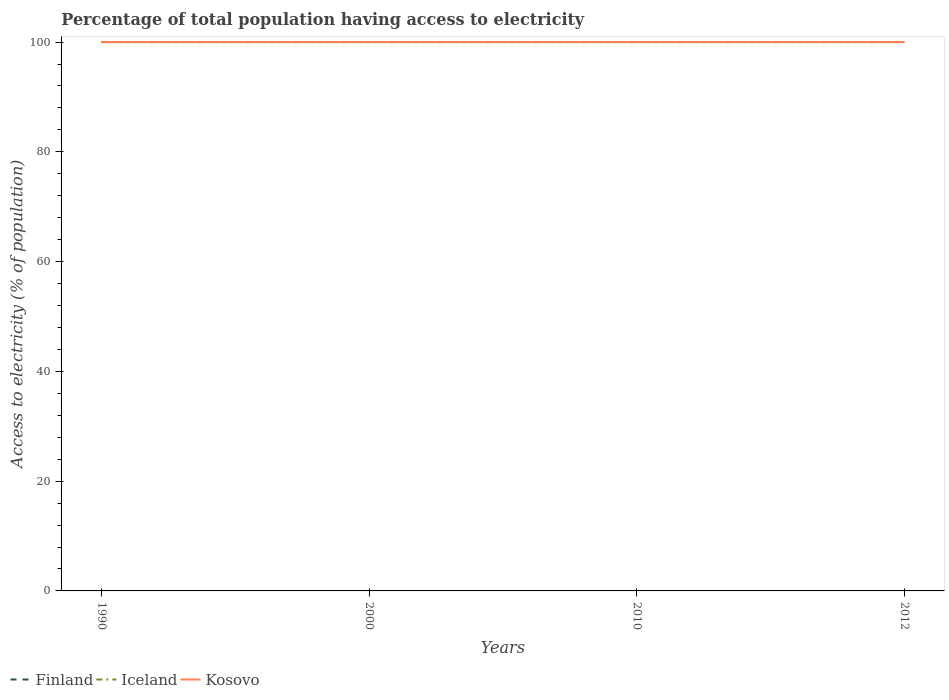How many different coloured lines are there?
Offer a terse response. 3. Is the number of lines equal to the number of legend labels?
Your response must be concise. Yes. Across all years, what is the maximum percentage of population that have access to electricity in Iceland?
Keep it short and to the point. 100. In which year was the percentage of population that have access to electricity in Kosovo maximum?
Make the answer very short. 1990. What is the difference between the highest and the lowest percentage of population that have access to electricity in Kosovo?
Offer a terse response. 0. How many lines are there?
Your answer should be very brief. 3. What is the difference between two consecutive major ticks on the Y-axis?
Offer a terse response. 20. How many legend labels are there?
Offer a very short reply. 3. What is the title of the graph?
Make the answer very short. Percentage of total population having access to electricity. Does "Congo (Democratic)" appear as one of the legend labels in the graph?
Your answer should be compact. No. What is the label or title of the Y-axis?
Your response must be concise. Access to electricity (% of population). What is the Access to electricity (% of population) of Iceland in 1990?
Ensure brevity in your answer.  100. What is the Access to electricity (% of population) of Iceland in 2000?
Provide a short and direct response. 100. What is the Access to electricity (% of population) of Kosovo in 2010?
Offer a terse response. 100. What is the Access to electricity (% of population) of Finland in 2012?
Your answer should be very brief. 100. What is the Access to electricity (% of population) in Iceland in 2012?
Your response must be concise. 100. Across all years, what is the maximum Access to electricity (% of population) of Iceland?
Offer a terse response. 100. Across all years, what is the minimum Access to electricity (% of population) in Kosovo?
Keep it short and to the point. 100. What is the total Access to electricity (% of population) of Kosovo in the graph?
Give a very brief answer. 400. What is the difference between the Access to electricity (% of population) in Iceland in 1990 and that in 2000?
Your answer should be very brief. 0. What is the difference between the Access to electricity (% of population) of Kosovo in 1990 and that in 2000?
Your answer should be compact. 0. What is the difference between the Access to electricity (% of population) of Kosovo in 1990 and that in 2010?
Offer a terse response. 0. What is the difference between the Access to electricity (% of population) of Finland in 1990 and that in 2012?
Offer a terse response. 0. What is the difference between the Access to electricity (% of population) in Kosovo in 2000 and that in 2010?
Your answer should be compact. 0. What is the difference between the Access to electricity (% of population) of Iceland in 2000 and that in 2012?
Your answer should be very brief. 0. What is the difference between the Access to electricity (% of population) of Kosovo in 2000 and that in 2012?
Offer a very short reply. 0. What is the difference between the Access to electricity (% of population) in Finland in 2010 and that in 2012?
Provide a short and direct response. 0. What is the difference between the Access to electricity (% of population) of Iceland in 2010 and that in 2012?
Your answer should be compact. 0. What is the difference between the Access to electricity (% of population) in Kosovo in 2010 and that in 2012?
Ensure brevity in your answer.  0. What is the difference between the Access to electricity (% of population) of Finland in 1990 and the Access to electricity (% of population) of Kosovo in 2000?
Give a very brief answer. 0. What is the difference between the Access to electricity (% of population) of Iceland in 1990 and the Access to electricity (% of population) of Kosovo in 2000?
Provide a short and direct response. 0. What is the difference between the Access to electricity (% of population) of Finland in 1990 and the Access to electricity (% of population) of Iceland in 2010?
Your response must be concise. 0. What is the difference between the Access to electricity (% of population) in Finland in 1990 and the Access to electricity (% of population) in Iceland in 2012?
Keep it short and to the point. 0. What is the difference between the Access to electricity (% of population) in Finland in 1990 and the Access to electricity (% of population) in Kosovo in 2012?
Offer a terse response. 0. What is the difference between the Access to electricity (% of population) in Iceland in 1990 and the Access to electricity (% of population) in Kosovo in 2012?
Offer a terse response. 0. What is the difference between the Access to electricity (% of population) of Finland in 2000 and the Access to electricity (% of population) of Iceland in 2010?
Your answer should be very brief. 0. What is the difference between the Access to electricity (% of population) of Finland in 2000 and the Access to electricity (% of population) of Kosovo in 2010?
Provide a short and direct response. 0. What is the difference between the Access to electricity (% of population) of Iceland in 2000 and the Access to electricity (% of population) of Kosovo in 2010?
Give a very brief answer. 0. What is the difference between the Access to electricity (% of population) of Finland in 2000 and the Access to electricity (% of population) of Kosovo in 2012?
Offer a terse response. 0. What is the difference between the Access to electricity (% of population) in Iceland in 2000 and the Access to electricity (% of population) in Kosovo in 2012?
Ensure brevity in your answer.  0. What is the difference between the Access to electricity (% of population) of Finland in 2010 and the Access to electricity (% of population) of Iceland in 2012?
Provide a short and direct response. 0. What is the difference between the Access to electricity (% of population) of Iceland in 2010 and the Access to electricity (% of population) of Kosovo in 2012?
Provide a short and direct response. 0. What is the average Access to electricity (% of population) of Finland per year?
Offer a very short reply. 100. What is the average Access to electricity (% of population) in Iceland per year?
Provide a succinct answer. 100. In the year 2000, what is the difference between the Access to electricity (% of population) in Finland and Access to electricity (% of population) in Iceland?
Your answer should be very brief. 0. In the year 2000, what is the difference between the Access to electricity (% of population) in Finland and Access to electricity (% of population) in Kosovo?
Offer a very short reply. 0. In the year 2000, what is the difference between the Access to electricity (% of population) in Iceland and Access to electricity (% of population) in Kosovo?
Provide a short and direct response. 0. In the year 2010, what is the difference between the Access to electricity (% of population) of Finland and Access to electricity (% of population) of Iceland?
Make the answer very short. 0. In the year 2010, what is the difference between the Access to electricity (% of population) in Finland and Access to electricity (% of population) in Kosovo?
Your response must be concise. 0. What is the ratio of the Access to electricity (% of population) of Finland in 1990 to that in 2000?
Your answer should be very brief. 1. What is the ratio of the Access to electricity (% of population) of Iceland in 1990 to that in 2000?
Make the answer very short. 1. What is the ratio of the Access to electricity (% of population) of Kosovo in 1990 to that in 2000?
Offer a terse response. 1. What is the ratio of the Access to electricity (% of population) of Iceland in 1990 to that in 2012?
Provide a succinct answer. 1. What is the ratio of the Access to electricity (% of population) of Kosovo in 1990 to that in 2012?
Keep it short and to the point. 1. What is the ratio of the Access to electricity (% of population) of Finland in 2000 to that in 2010?
Provide a short and direct response. 1. What is the ratio of the Access to electricity (% of population) of Iceland in 2000 to that in 2010?
Your response must be concise. 1. What is the ratio of the Access to electricity (% of population) in Kosovo in 2000 to that in 2010?
Offer a very short reply. 1. What is the ratio of the Access to electricity (% of population) of Iceland in 2000 to that in 2012?
Offer a very short reply. 1. What is the ratio of the Access to electricity (% of population) in Finland in 2010 to that in 2012?
Offer a very short reply. 1. What is the ratio of the Access to electricity (% of population) of Kosovo in 2010 to that in 2012?
Keep it short and to the point. 1. What is the difference between the highest and the second highest Access to electricity (% of population) in Kosovo?
Offer a terse response. 0. What is the difference between the highest and the lowest Access to electricity (% of population) of Finland?
Give a very brief answer. 0. What is the difference between the highest and the lowest Access to electricity (% of population) of Iceland?
Offer a terse response. 0. 